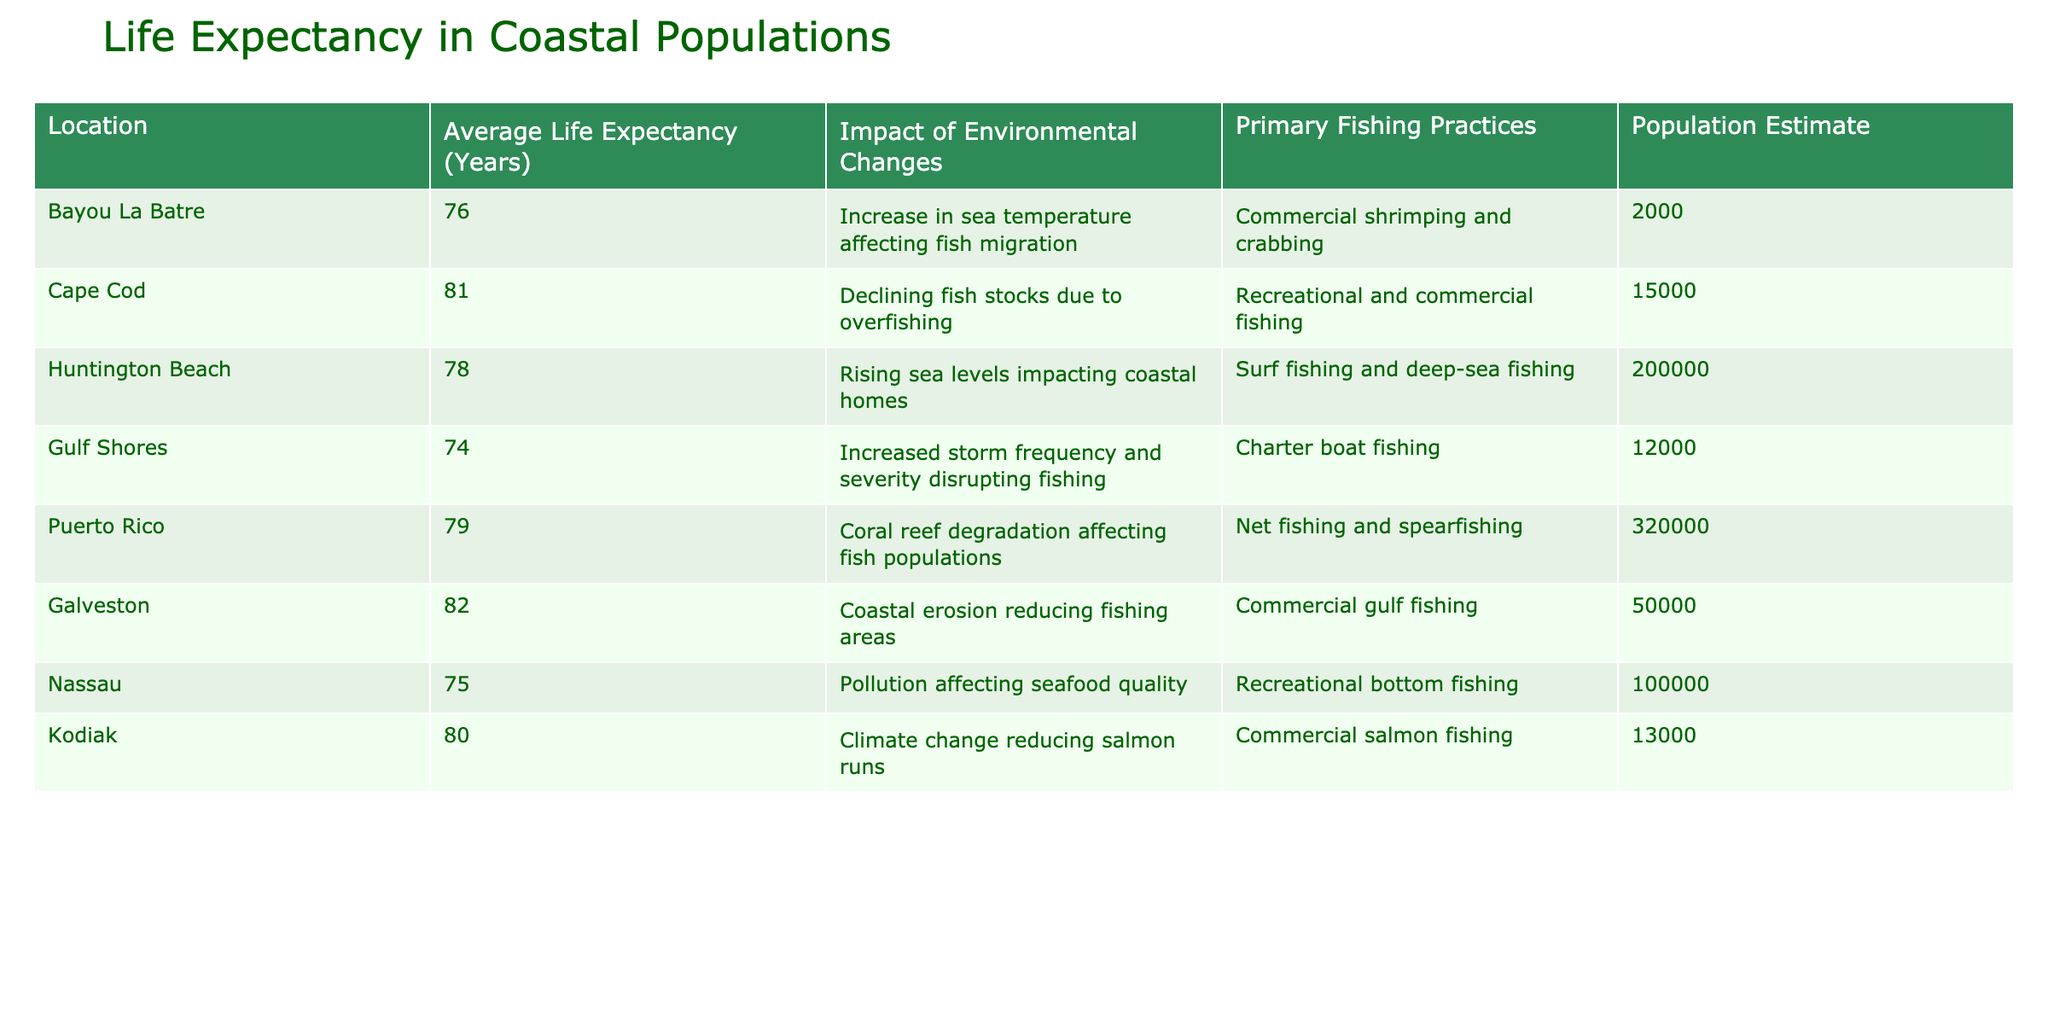What is the average life expectancy of the locations listed? To find the average, sum the life expectancies (76 + 81 + 78 + 74 + 79 + 82 + 75 + 80) which is 605. There are 8 locations, so divide by 8: 605 / 8 = 75.625. Thus, the average life expectancy rounded to the nearest whole number is 76.
Answer: 76 Which location has the highest life expectancy? By examining the life expectancy values, Galveston has the highest at 82 years.
Answer: Galveston Is the life expectancy of Cape Cod higher than that of Nassau? Cape Cod's life expectancy is 81 years, while Nassau's is 75 years. Since 81 is greater than 75, the answer is yes.
Answer: Yes What is the difference in life expectancy between Huntington Beach and Gulf Shores? Huntington Beach has a life expectancy of 78 years and Gulf Shores has 74 years. The difference is 78 - 74 = 4 years.
Answer: 4 How many locations have a life expectancy above 80 years? The locations with above 80 years are Cape Cod (81) and Galveston (82), which gives us 2 locations.
Answer: 2 Does pollution affect life expectancy in Nassau? The data indicates that pollution is affecting seafood quality in Nassau, which could imply a negative impact on life expectancy. Thus, yes, pollution does affect it.
Answer: Yes If we consider locations with a primary practice of commercial fishing, what is their average life expectancy? The locations are Bayou La Batre (76), Galveston (82), and Kodiak (80). Their total life expectancy is 76 + 82 + 80 = 238. Since there are 3 locations, the average is 238 / 3 = 79.33, rounded to 79.
Answer: 79 What is the estimated population of locations that experience coral reef degradation? Only Puerto Rico is listed as experiencing coral reef degradation, with a population of 320,000.
Answer: 320000 How many locations experience a decrease in life expectancy due to storm activity? Gulf Shores is mentioned for increased storm frequency and severity disrupting fishing. Since it is the only one, the answer is 1 location.
Answer: 1 